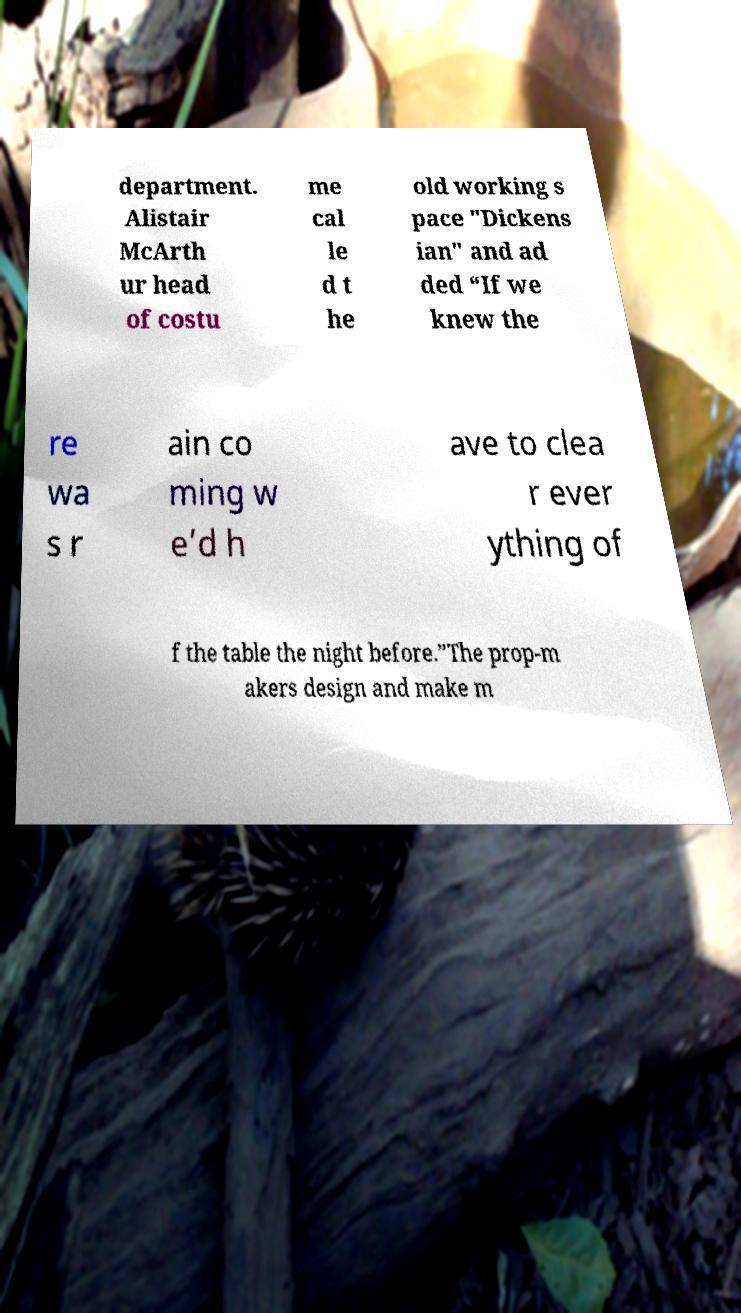I need the written content from this picture converted into text. Can you do that? department. Alistair McArth ur head of costu me cal le d t he old working s pace "Dickens ian" and ad ded “If we knew the re wa s r ain co ming w e’d h ave to clea r ever ything of f the table the night before.”The prop-m akers design and make m 